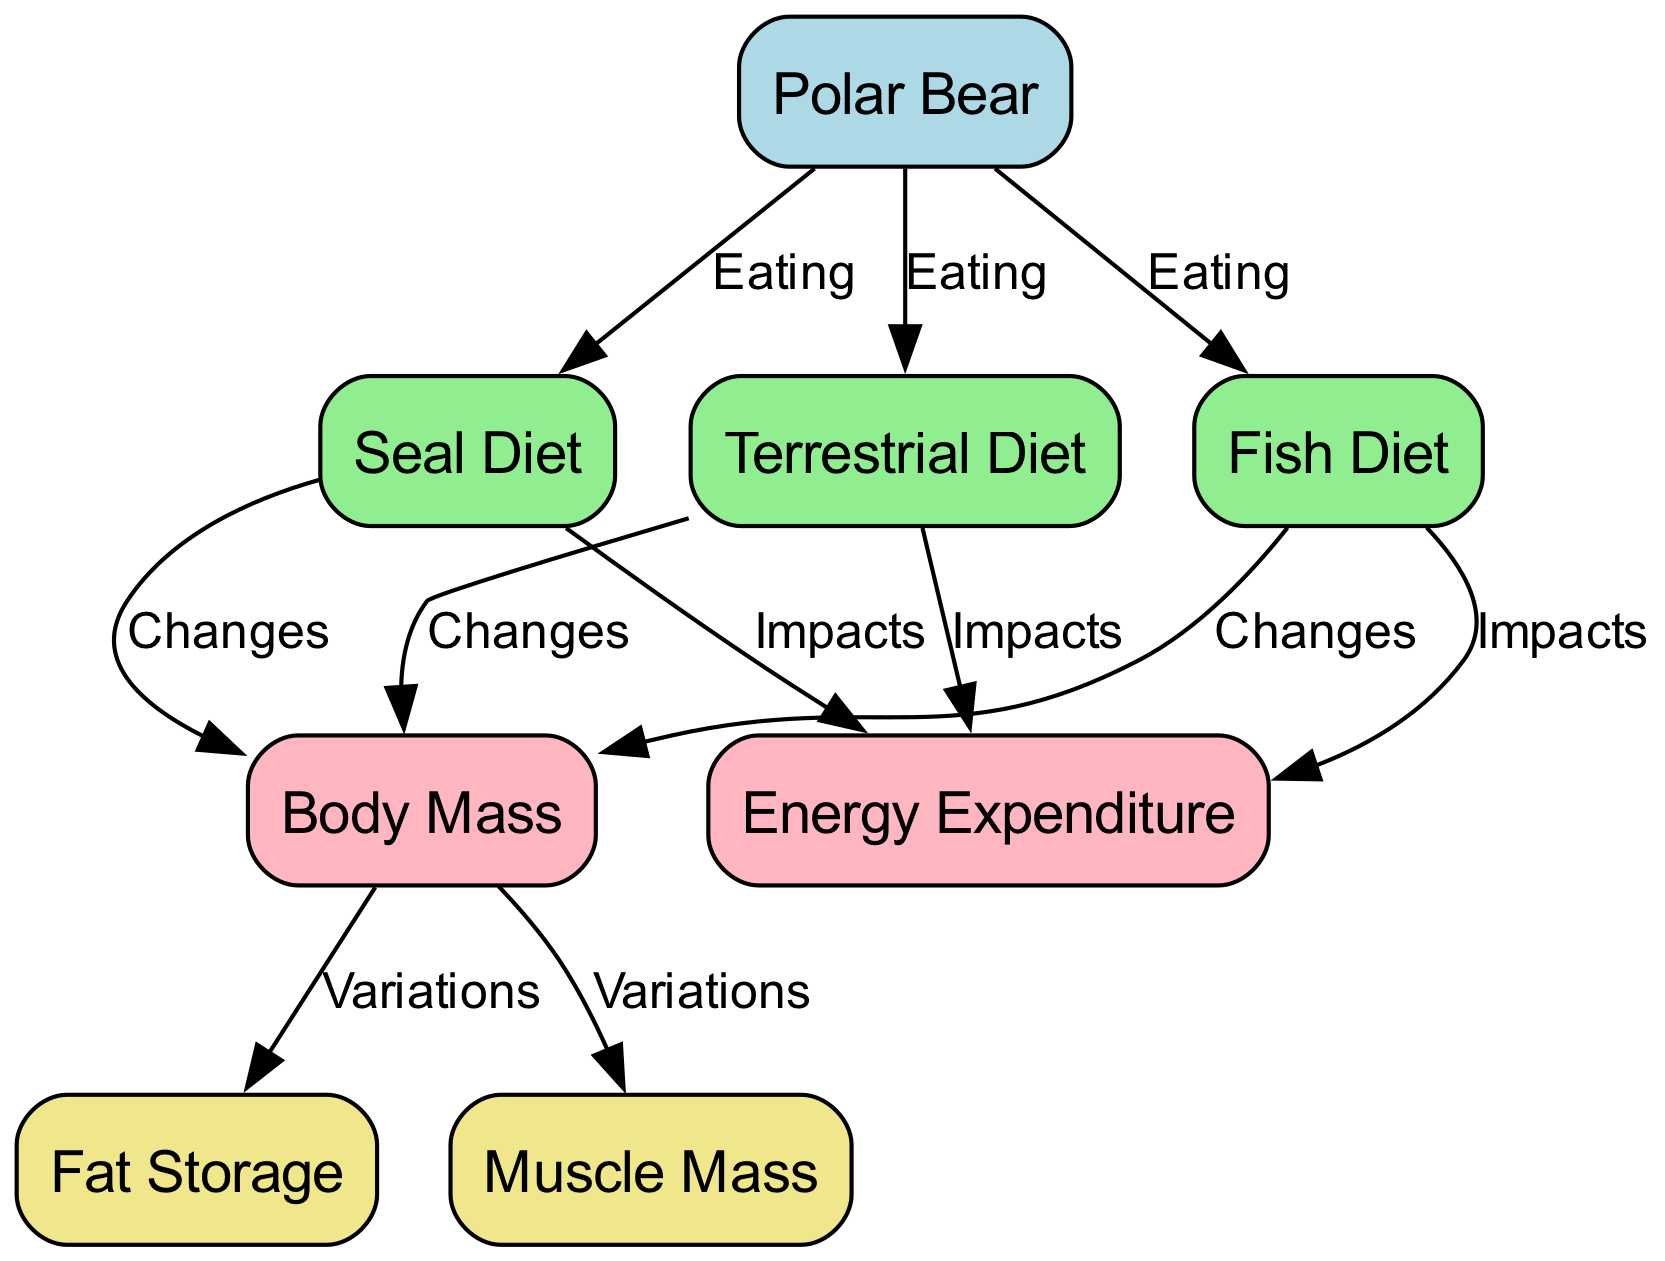What are the three diets mentioned for a polar bear? The diagram lists three diets for the polar bear: Seal Diet, Fish Diet, and Terrestrial Diet. These can be identified as the nodes connected to the polar bear in the "Eating" relationship.
Answer: Seal Diet, Fish Diet, Terrestrial Diet How many impacts does each diet have on energy expenditure? Each diet, Seal Diet, Fish Diet, and Terrestrial Diet, has one impact on energy expenditure, which is shown through the directed edges from each diet node to the energy expenditure node. This indicates that all three diets influence energy expenditure directly.
Answer: One each What changes occur in body mass with a Terrestrial Diet? According to the diagram, the Terrestrial Diet shows a "Changes" relationship pointing to the body mass node. This signifies that the Terrestrial Diet affects the body mass of the polar bear directly.
Answer: Changes occur Which two components vary as a result of changes in body mass? The diagram indicates that variations in body mass lead to two components: fat storage and muscle mass. This is observable through the directed edges from the body mass node to each of these components.
Answer: Fat storage, muscle mass Which diet results in the most significant impact on body mass? While the diagram does not quantify impacts, it implies that all three diets (Seal, Fish, and Terrestrial) impact body mass without specifying which one is most significant. The relationships indicate that they all cause changes, hence one cannot conclude which is greatest without additional data.
Answer: Not specified What is the primary focus of the diagram? The diagram primarily focuses on tracking the metabolic response of a polar bear to different diets, specifically how these diets affect energy expenditure and body mass. This is evident from the central connections between the polar bear and various diets, as well as the outcomes measured.
Answer: Metabolic response to diets How many nodes does the diagram contain? The diagram contains a total of seven nodes, which include one polar bear node, three diet nodes, and three measurement nodes (energy expenditure, body mass, fat storage, and muscle mass). This is obtained by counting each distinct node listed in the data.
Answer: Seven nodes What do the edges from diets to energy expenditure signify? The edges from each diet to energy expenditure signify that each diet has an impact on the energy expenditure of the polar bear. Each directed edge represents a causal relationship where the specific diet influences the energy expenditure measurement.
Answer: Impacts on energy expenditure What are the main measurements depicted in the diagram? The main measurements depicted in the diagram are energy expenditure, body mass, fat storage, and muscle mass. These are identified as measurement nodes, and they illustrate key components involved in assessing the polar bear's adaptation to its diet.
Answer: Energy expenditure, body mass, fat storage, muscle mass 